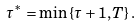<formula> <loc_0><loc_0><loc_500><loc_500>\tau ^ { * } = \min \left \{ \tau + 1 , T \right \} .</formula> 